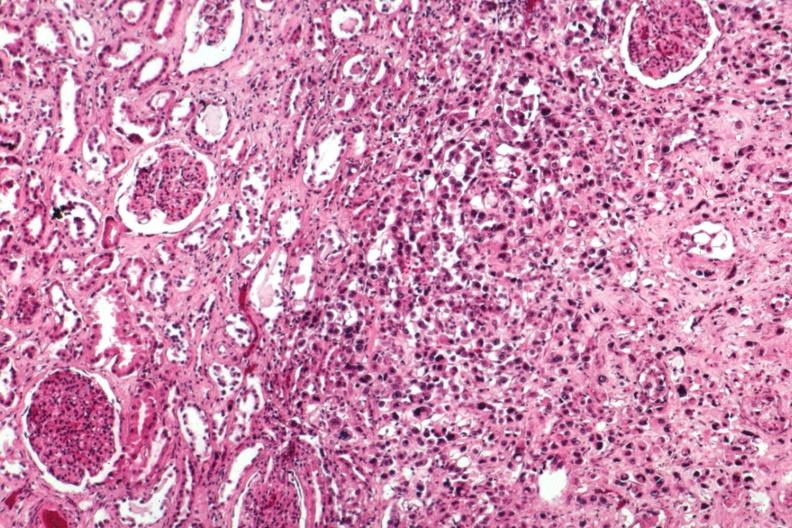s kidney present?
Answer the question using a single word or phrase. Yes 